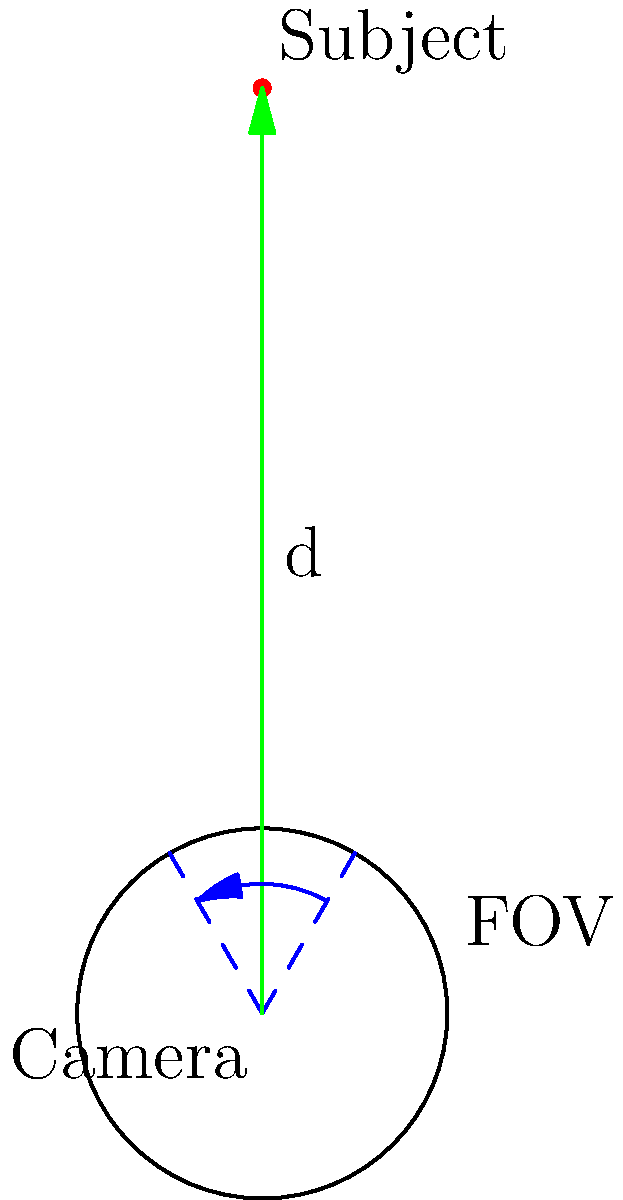As a wildlife photographer, you're attempting to capture an image of a rare, small primate in a dense forest. Given that your camera has a focal length of 200mm and an aperture of f/4, and the primate is estimated to be 5 meters away, calculate the depth of field. Assume the circle of confusion for your camera is 0.02mm. How does this affect your strategy for capturing a clear image of the elusive creature? To solve this problem, we need to follow these steps:

1. Calculate the hyperfocal distance:
   $H = \frac{f^2}{N * c} + f$
   Where:
   $f$ = focal length (200mm)
   $N$ = f-number (4)
   $c$ = circle of confusion (0.02mm)

   $H = \frac{200^2}{4 * 0.02} + 200 = 500,200\text{ mm} = 500.2\text{ m}$

2. Calculate the near limit of depth of field:
   $D_n = \frac{s(H-f)}{H+s-2f}$
   Where $s$ = subject distance (5m = 5000mm)

   $D_n = \frac{5000(500200-200)}{500200+5000-400} = 4,975.05\text{ mm} = 4.98\text{ m}$

3. Calculate the far limit of depth of field:
   $D_f = \frac{s(H-f)}{H-s}$

   $D_f = \frac{5000(500200-200)}{500200-5000} = 5,025.05\text{ mm} = 5.03\text{ m}$

4. Calculate the total depth of field:
   $\text{DOF} = D_f - D_n = 5.03 - 4.98 = 0.05\text{ m} = 5\text{ cm}$

The depth of field is very shallow at only 5 cm. This affects the photography strategy in several ways:
1. The photographer must be extremely precise with focusing, as even a slight movement of the camera or subject could result in an out-of-focus image.
2. Using a tripod or image stabilization becomes crucial to maintain sharpness.
3. The photographer might consider using a smaller aperture (higher f-number) to increase the depth of field, but this would require more light or a higher ISO setting.
4. Alternatively, moving further away from the subject would increase the depth of field but might make it harder to capture detail on the small primate.
Answer: Depth of field: 5 cm. Strategy: Precise focus, use tripod, consider smaller aperture or greater distance. 